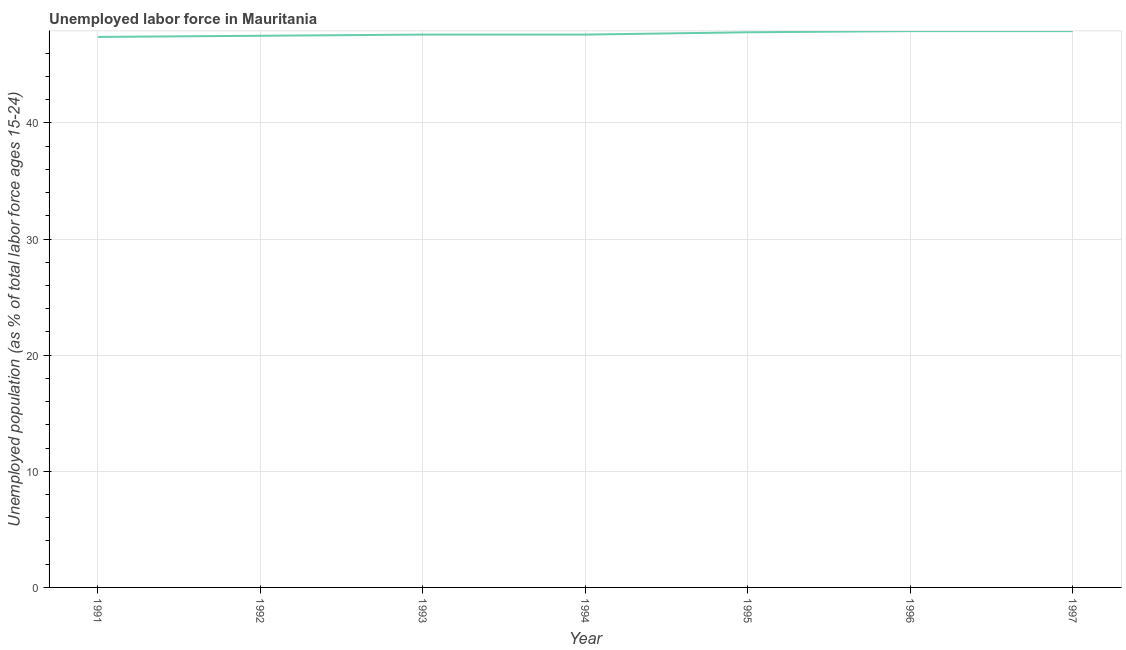What is the total unemployed youth population in 1996?
Ensure brevity in your answer.  47.9. Across all years, what is the maximum total unemployed youth population?
Provide a succinct answer. 47.9. Across all years, what is the minimum total unemployed youth population?
Provide a short and direct response. 47.4. In which year was the total unemployed youth population maximum?
Offer a terse response. 1996. In which year was the total unemployed youth population minimum?
Provide a succinct answer. 1991. What is the sum of the total unemployed youth population?
Provide a short and direct response. 333.7. What is the difference between the total unemployed youth population in 1991 and 1992?
Give a very brief answer. -0.1. What is the average total unemployed youth population per year?
Provide a short and direct response. 47.67. What is the median total unemployed youth population?
Keep it short and to the point. 47.6. Do a majority of the years between 1996 and 1993 (inclusive) have total unemployed youth population greater than 44 %?
Your answer should be compact. Yes. What is the ratio of the total unemployed youth population in 1992 to that in 1997?
Your answer should be very brief. 0.99. Is the sum of the total unemployed youth population in 1994 and 1995 greater than the maximum total unemployed youth population across all years?
Offer a terse response. Yes. Does the total unemployed youth population monotonically increase over the years?
Your response must be concise. No. How many lines are there?
Ensure brevity in your answer.  1. Are the values on the major ticks of Y-axis written in scientific E-notation?
Provide a short and direct response. No. What is the title of the graph?
Provide a short and direct response. Unemployed labor force in Mauritania. What is the label or title of the Y-axis?
Your answer should be very brief. Unemployed population (as % of total labor force ages 15-24). What is the Unemployed population (as % of total labor force ages 15-24) of 1991?
Provide a short and direct response. 47.4. What is the Unemployed population (as % of total labor force ages 15-24) in 1992?
Provide a succinct answer. 47.5. What is the Unemployed population (as % of total labor force ages 15-24) in 1993?
Provide a succinct answer. 47.6. What is the Unemployed population (as % of total labor force ages 15-24) in 1994?
Your answer should be compact. 47.6. What is the Unemployed population (as % of total labor force ages 15-24) of 1995?
Offer a terse response. 47.8. What is the Unemployed population (as % of total labor force ages 15-24) of 1996?
Provide a short and direct response. 47.9. What is the Unemployed population (as % of total labor force ages 15-24) in 1997?
Ensure brevity in your answer.  47.9. What is the difference between the Unemployed population (as % of total labor force ages 15-24) in 1991 and 1992?
Make the answer very short. -0.1. What is the difference between the Unemployed population (as % of total labor force ages 15-24) in 1991 and 1993?
Offer a terse response. -0.2. What is the difference between the Unemployed population (as % of total labor force ages 15-24) in 1992 and 1993?
Keep it short and to the point. -0.1. What is the difference between the Unemployed population (as % of total labor force ages 15-24) in 1992 and 1994?
Provide a short and direct response. -0.1. What is the difference between the Unemployed population (as % of total labor force ages 15-24) in 1992 and 1995?
Keep it short and to the point. -0.3. What is the difference between the Unemployed population (as % of total labor force ages 15-24) in 1992 and 1996?
Give a very brief answer. -0.4. What is the difference between the Unemployed population (as % of total labor force ages 15-24) in 1992 and 1997?
Your response must be concise. -0.4. What is the difference between the Unemployed population (as % of total labor force ages 15-24) in 1993 and 1994?
Give a very brief answer. 0. What is the difference between the Unemployed population (as % of total labor force ages 15-24) in 1993 and 1995?
Offer a very short reply. -0.2. What is the difference between the Unemployed population (as % of total labor force ages 15-24) in 1993 and 1996?
Your answer should be compact. -0.3. What is the difference between the Unemployed population (as % of total labor force ages 15-24) in 1993 and 1997?
Offer a very short reply. -0.3. What is the difference between the Unemployed population (as % of total labor force ages 15-24) in 1994 and 1997?
Keep it short and to the point. -0.3. What is the difference between the Unemployed population (as % of total labor force ages 15-24) in 1995 and 1996?
Keep it short and to the point. -0.1. What is the difference between the Unemployed population (as % of total labor force ages 15-24) in 1996 and 1997?
Make the answer very short. 0. What is the ratio of the Unemployed population (as % of total labor force ages 15-24) in 1991 to that in 1992?
Offer a very short reply. 1. What is the ratio of the Unemployed population (as % of total labor force ages 15-24) in 1991 to that in 1995?
Offer a very short reply. 0.99. What is the ratio of the Unemployed population (as % of total labor force ages 15-24) in 1991 to that in 1996?
Provide a succinct answer. 0.99. What is the ratio of the Unemployed population (as % of total labor force ages 15-24) in 1992 to that in 1996?
Give a very brief answer. 0.99. What is the ratio of the Unemployed population (as % of total labor force ages 15-24) in 1992 to that in 1997?
Your answer should be very brief. 0.99. What is the ratio of the Unemployed population (as % of total labor force ages 15-24) in 1993 to that in 1994?
Ensure brevity in your answer.  1. What is the ratio of the Unemployed population (as % of total labor force ages 15-24) in 1993 to that in 1996?
Your answer should be very brief. 0.99. What is the ratio of the Unemployed population (as % of total labor force ages 15-24) in 1993 to that in 1997?
Give a very brief answer. 0.99. What is the ratio of the Unemployed population (as % of total labor force ages 15-24) in 1994 to that in 1996?
Provide a short and direct response. 0.99. What is the ratio of the Unemployed population (as % of total labor force ages 15-24) in 1994 to that in 1997?
Keep it short and to the point. 0.99. What is the ratio of the Unemployed population (as % of total labor force ages 15-24) in 1995 to that in 1996?
Ensure brevity in your answer.  1. What is the ratio of the Unemployed population (as % of total labor force ages 15-24) in 1995 to that in 1997?
Keep it short and to the point. 1. 